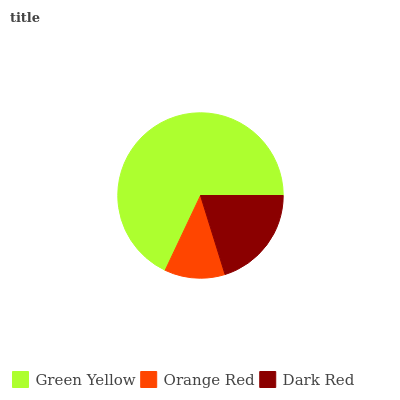Is Orange Red the minimum?
Answer yes or no. Yes. Is Green Yellow the maximum?
Answer yes or no. Yes. Is Dark Red the minimum?
Answer yes or no. No. Is Dark Red the maximum?
Answer yes or no. No. Is Dark Red greater than Orange Red?
Answer yes or no. Yes. Is Orange Red less than Dark Red?
Answer yes or no. Yes. Is Orange Red greater than Dark Red?
Answer yes or no. No. Is Dark Red less than Orange Red?
Answer yes or no. No. Is Dark Red the high median?
Answer yes or no. Yes. Is Dark Red the low median?
Answer yes or no. Yes. Is Green Yellow the high median?
Answer yes or no. No. Is Green Yellow the low median?
Answer yes or no. No. 